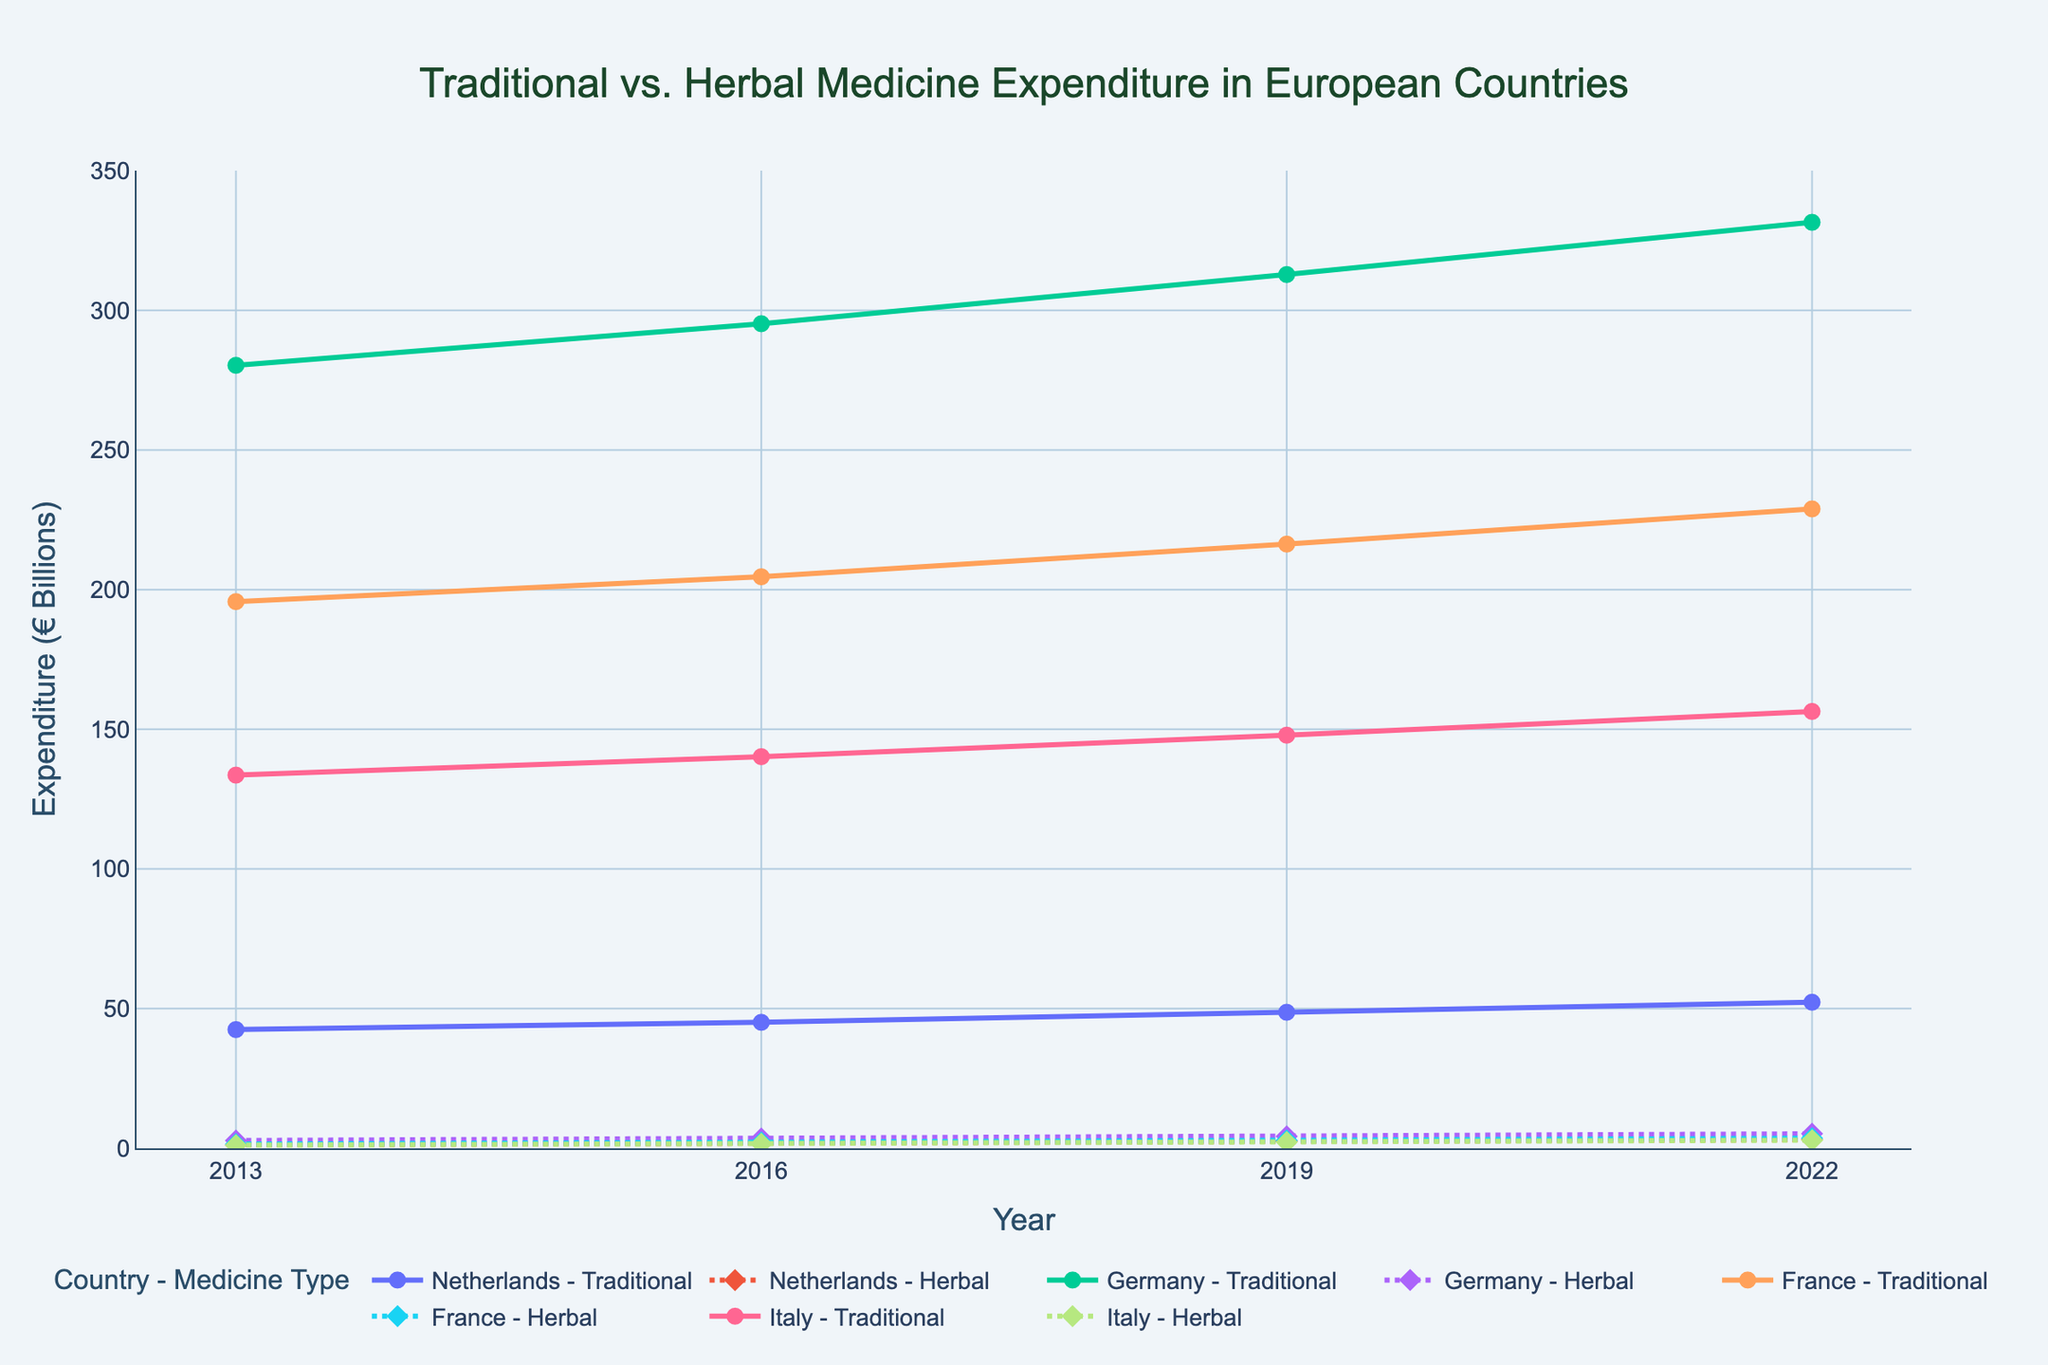Which country had the highest traditional medicine expenditure in 2022? To find the highest traditional medicine expenditure in 2022, look at that year and compare the expenditures for each country. Germany has the highest expenditure at €331.5 billion.
Answer: Germany What was the increase in herbal medicine expenditure in the Netherlands from 2013 to 2022? Subtract the herbal medicine expenditure of the Netherlands in 2013 from that in 2022. (€3.1 billion - €1.2 billion = €1.9 billion)
Answer: €1.9 billion How does the herbal medicine expenditure in France in 2019 compare to that in 2016? Look at the herbal medicine expenditure in France for both 2016 (€2.1 billion) and 2019 (€2.8 billion) and subtract to find the difference. (€2.8 billion - €2.1 billion = €0.7 billion)
Answer: €0.7 billion increase Between 2013 and 2022, which country showed the greatest relative increase in herbal medicine expenditure? Calculate the relative increase for each country by using the formula [(Expenditure in 2022 - Expenditure in 2013) / Expenditure in 2013]. The Netherlands has the highest relative increase: ([(€3.1 billion - €1.2 billion) / €1.2 billion] * 100 ≈ 158%).
Answer: Netherlands Which country had the smallest increase in traditional medicine expenditure from 2013 to 2022? Compare the traditional medicine expenditure increase of each country from 2013 to 2022. Italy's increase is the smallest: (€156.4 billion - €133.6 billion = €22.8 billion).
Answer: Italy What was the total herbal medicine expenditure across all listed countries in 2019? Sum the herbal medicine expenditures of all countries in 2019. (€2.5 billion + €4.3 billion + €2.8 billion + €2.2 billion = €11.8 billion)
Answer: €11.8 billion By what factor did the herbal medicine expenditure in Germany increase from 2013 to 2022? Divide the expenditure of 2022 by the expenditure of 2013. (€5.2 billion / €2.8 billion ≈ 1.86)
Answer: 1.86 Which country had a larger expenditure on herbal medicine in 2016: Netherlands or Italy? Compare the herbal medicine expenditures of the Netherlands (€1.8 billion) and Italy (€1.6 billion) in 2016. The Netherlands had a larger expenditure.
Answer: Netherlands 